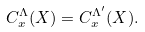Convert formula to latex. <formula><loc_0><loc_0><loc_500><loc_500>C _ { x } ^ { \Lambda } ( X ) = C _ { x } ^ { \Lambda ^ { \prime } } ( X ) .</formula> 